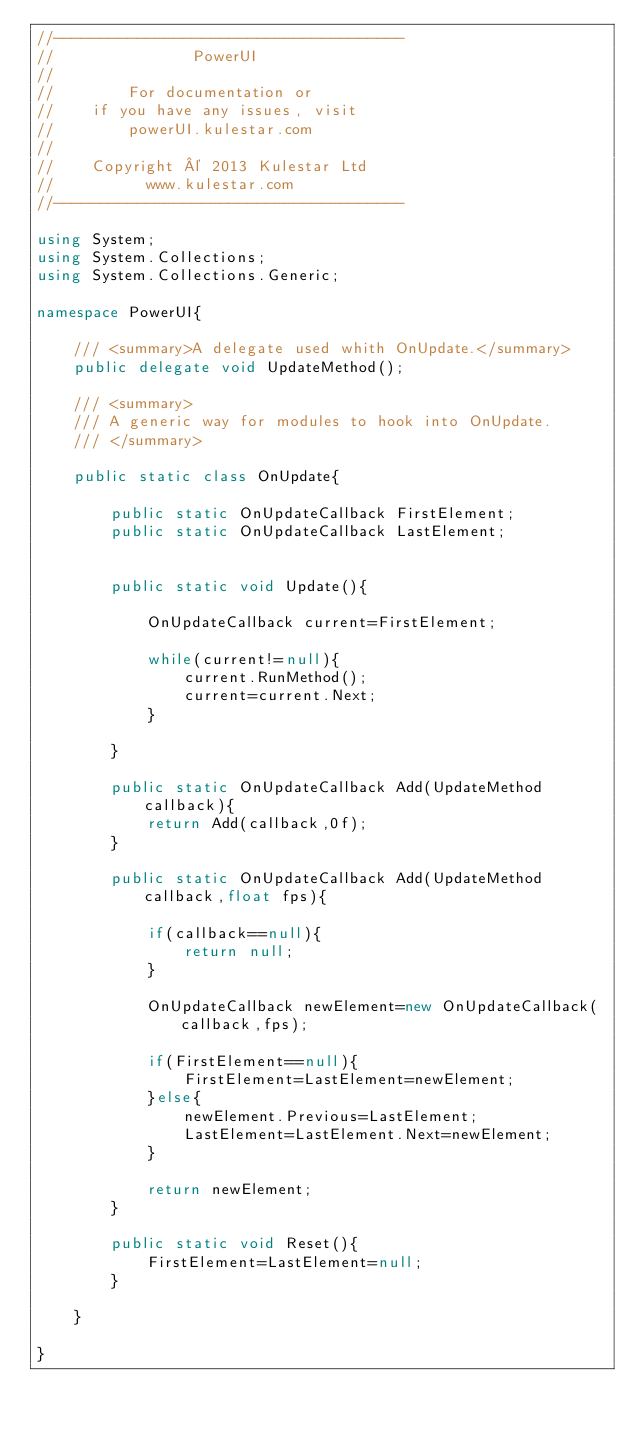<code> <loc_0><loc_0><loc_500><loc_500><_C#_>//--------------------------------------
//               PowerUI
//
//        For documentation or 
//    if you have any issues, visit
//        powerUI.kulestar.com
//
//    Copyright © 2013 Kulestar Ltd
//          www.kulestar.com
//--------------------------------------

using System;
using System.Collections;
using System.Collections.Generic;

namespace PowerUI{

	/// <summary>A delegate used whith OnUpdate.</summary>
	public delegate void UpdateMethod();

	/// <summary>
	/// A generic way for modules to hook into OnUpdate.
	/// </summary>
	
	public static class OnUpdate{
		
		public static OnUpdateCallback FirstElement;
		public static OnUpdateCallback LastElement;
		
		
		public static void Update(){
			
			OnUpdateCallback current=FirstElement;
			
			while(current!=null){
				current.RunMethod();
				current=current.Next;
			}
			
		}
		
		public static OnUpdateCallback Add(UpdateMethod callback){
			return Add(callback,0f);
		}
		
		public static OnUpdateCallback Add(UpdateMethod callback,float fps){
			
			if(callback==null){
				return null;
			}
			
			OnUpdateCallback newElement=new OnUpdateCallback(callback,fps);
			
			if(FirstElement==null){
				FirstElement=LastElement=newElement;
			}else{
				newElement.Previous=LastElement;
				LastElement=LastElement.Next=newElement;
			}
			
			return newElement;
		}
		
		public static void Reset(){
			FirstElement=LastElement=null;
		}
		
	}

}</code> 